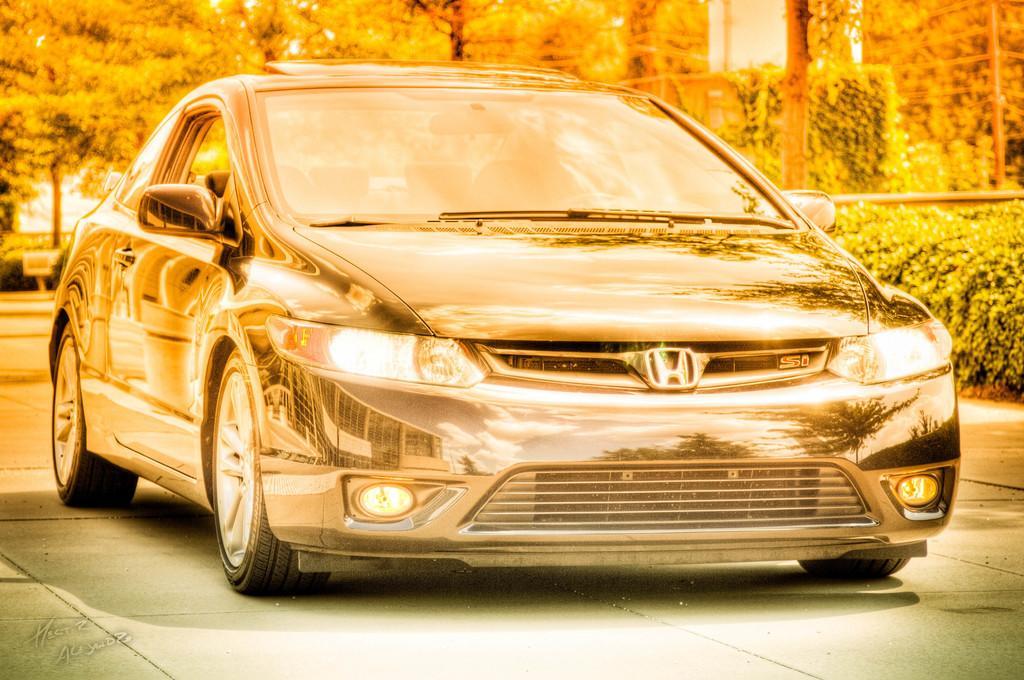Describe this image in one or two sentences. This is an edited image. Here I can see a car on the ground. In the background there are many trees. On the right side there are some plants. 